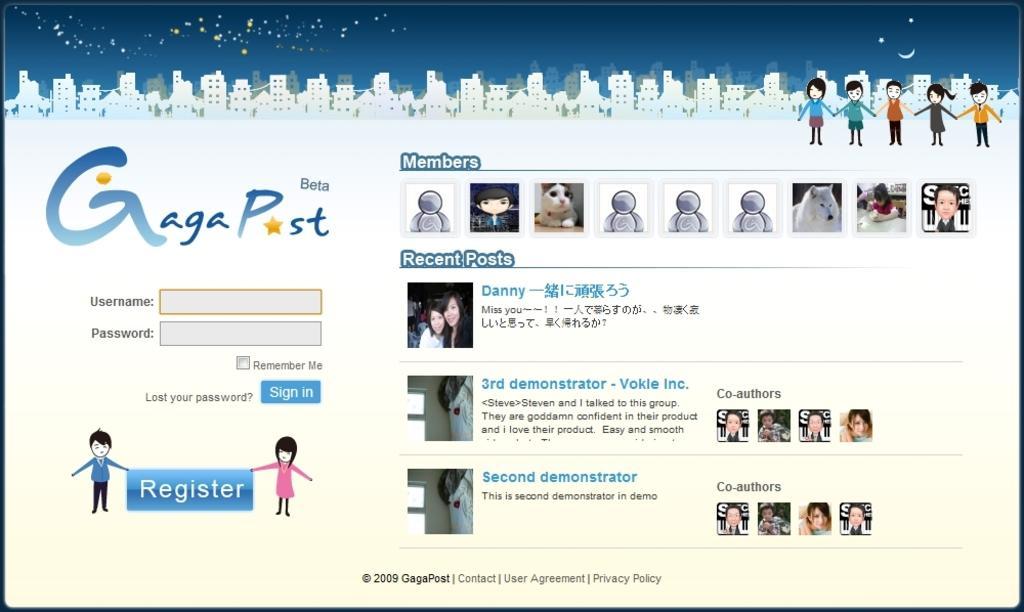How would you summarize this image in a sentence or two? In this picture we can see a web page, on this web page we can see people, buildings, dog, symbols and some text on it. 